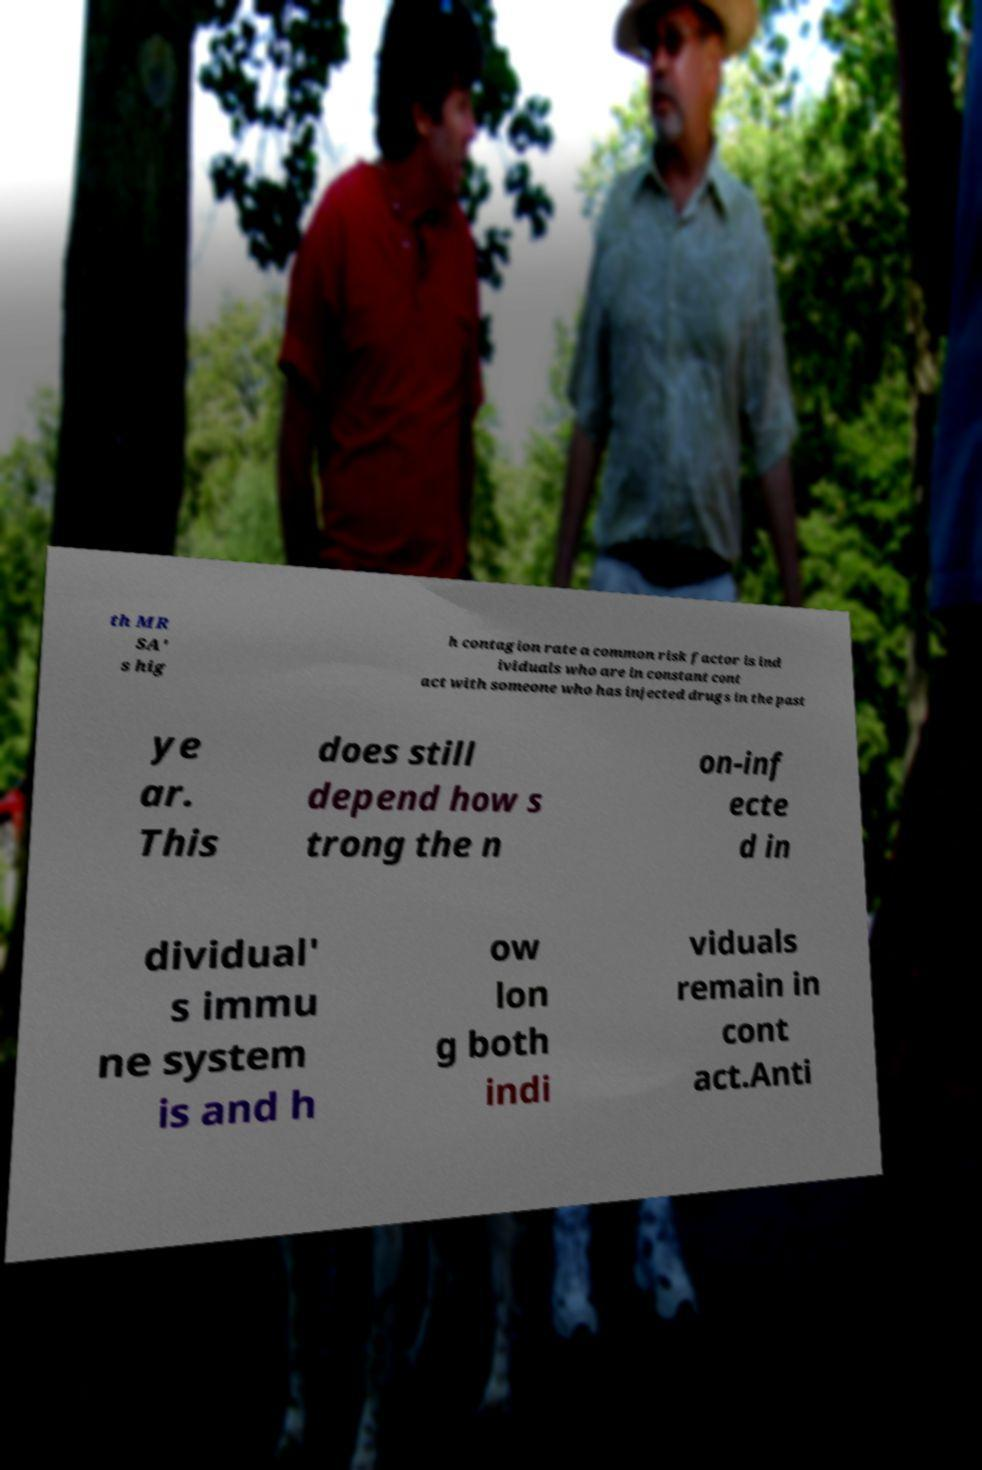Can you accurately transcribe the text from the provided image for me? th MR SA' s hig h contagion rate a common risk factor is ind ividuals who are in constant cont act with someone who has injected drugs in the past ye ar. This does still depend how s trong the n on-inf ecte d in dividual' s immu ne system is and h ow lon g both indi viduals remain in cont act.Anti 